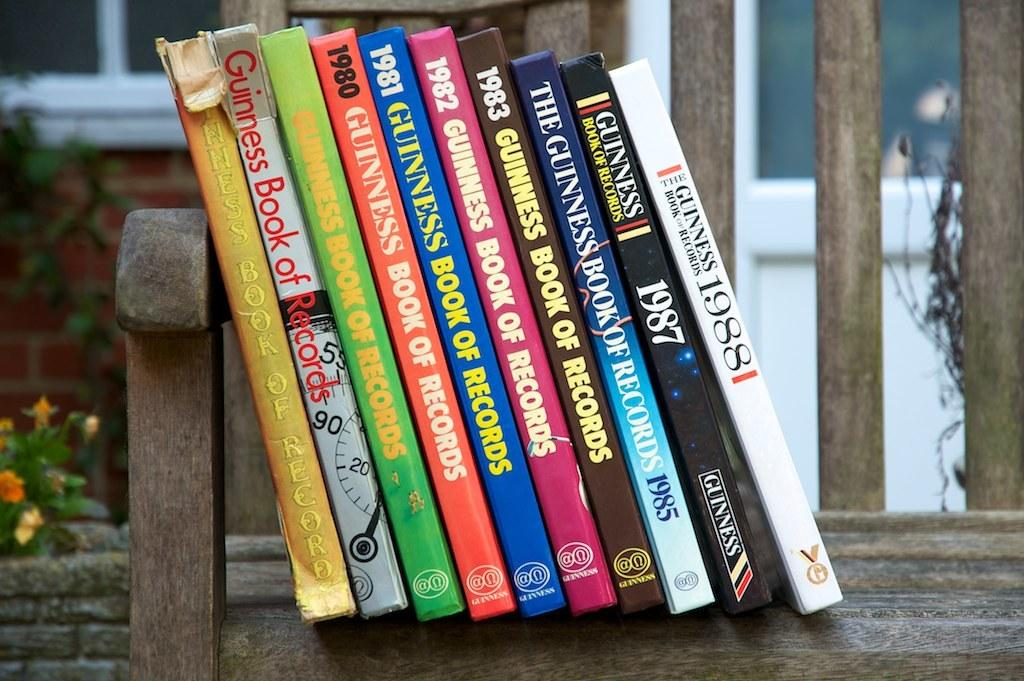<image>
Provide a brief description of the given image. A stack of books of the Guinness book of world records. 